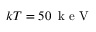<formula> <loc_0><loc_0><loc_500><loc_500>k T = 5 0 \, k e V</formula> 